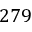<formula> <loc_0><loc_0><loc_500><loc_500>2 7 9</formula> 